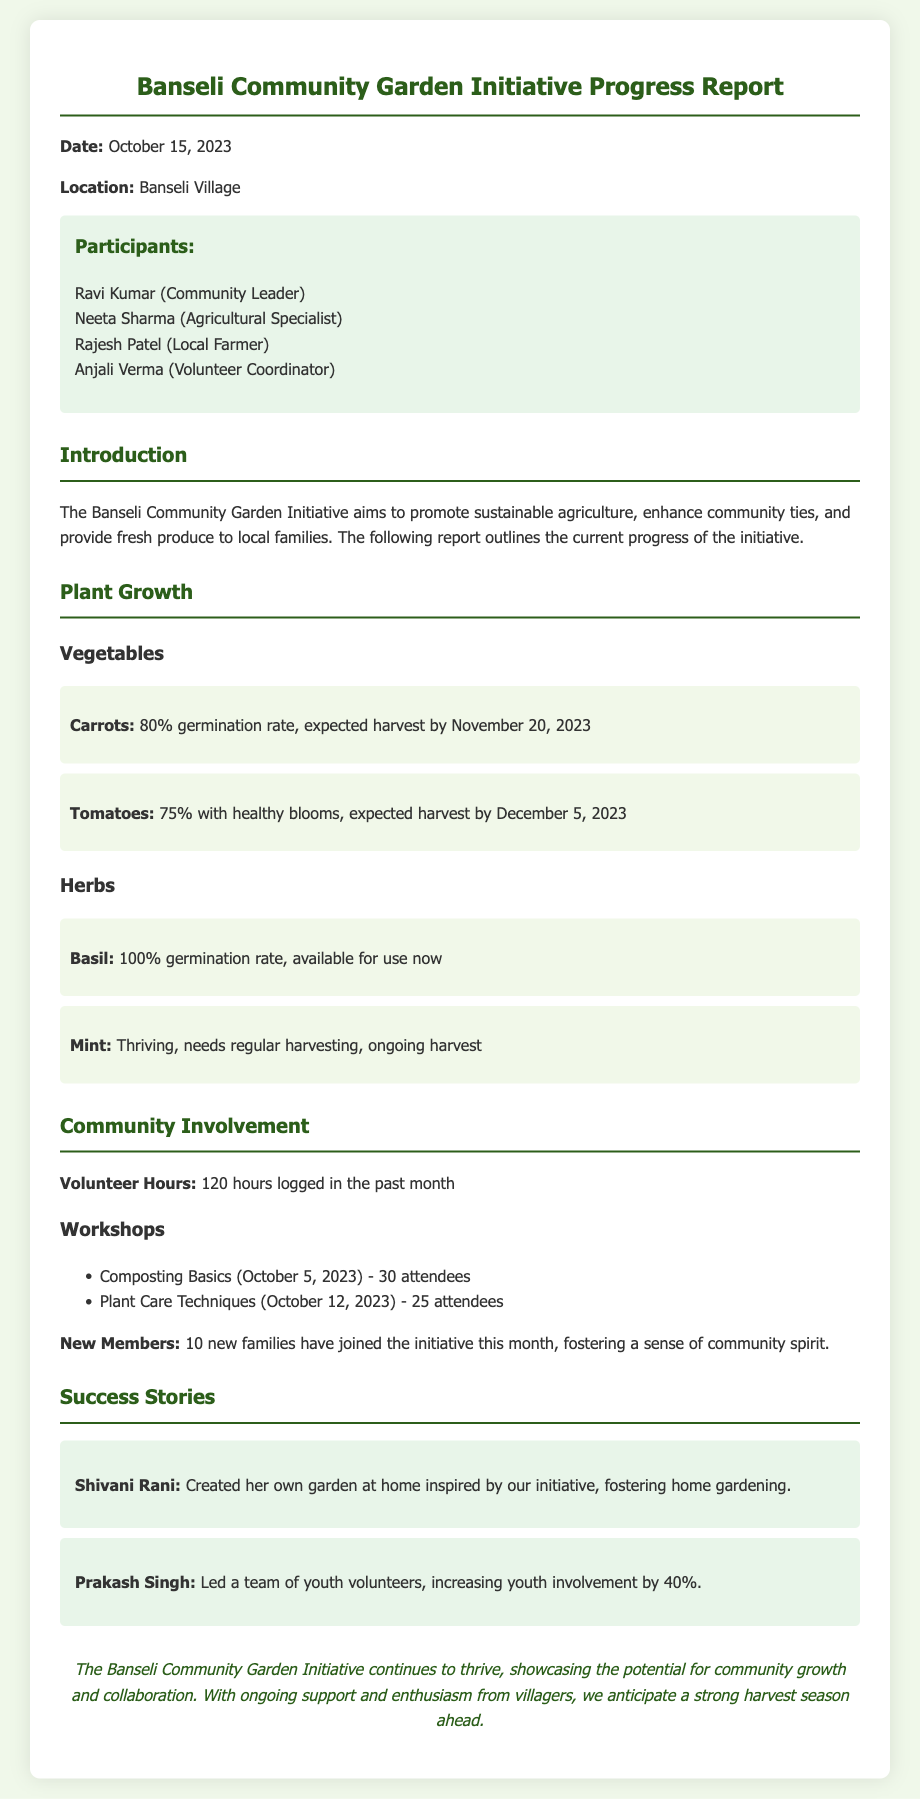What is the date of the report? The report is dated October 15, 2023.
Answer: October 15, 2023 How many hours were logged by volunteers in the past month? The document states that 120 hours were logged in the past month.
Answer: 120 hours What is the germination rate of carrots? The document specifies an 80% germination rate for carrots.
Answer: 80% How many new families joined the initiative this month? According to the report, 10 new families have joined the initiative this month.
Answer: 10 What vegetable is expected to harvest by December 5, 2023? The report indicates that tomatoes are expected to be harvested by December 5, 2023.
Answer: Tomatoes What workshop had the most attendees? The Composting Basics workshop had 30 attendees, which is the highest number reported.
Answer: Composting Basics Which herb has a 100% germination rate? The report mentions that basil has a 100% germination rate.
Answer: Basil Who is the local farmer participating in the initiative? Rajesh Patel is mentioned as the local farmer participating in the initiative.
Answer: Rajesh Patel What success story highlights increased youth involvement? Prakash Singh's story mentions an increase in youth involvement by 40%.
Answer: Prakash Singh 